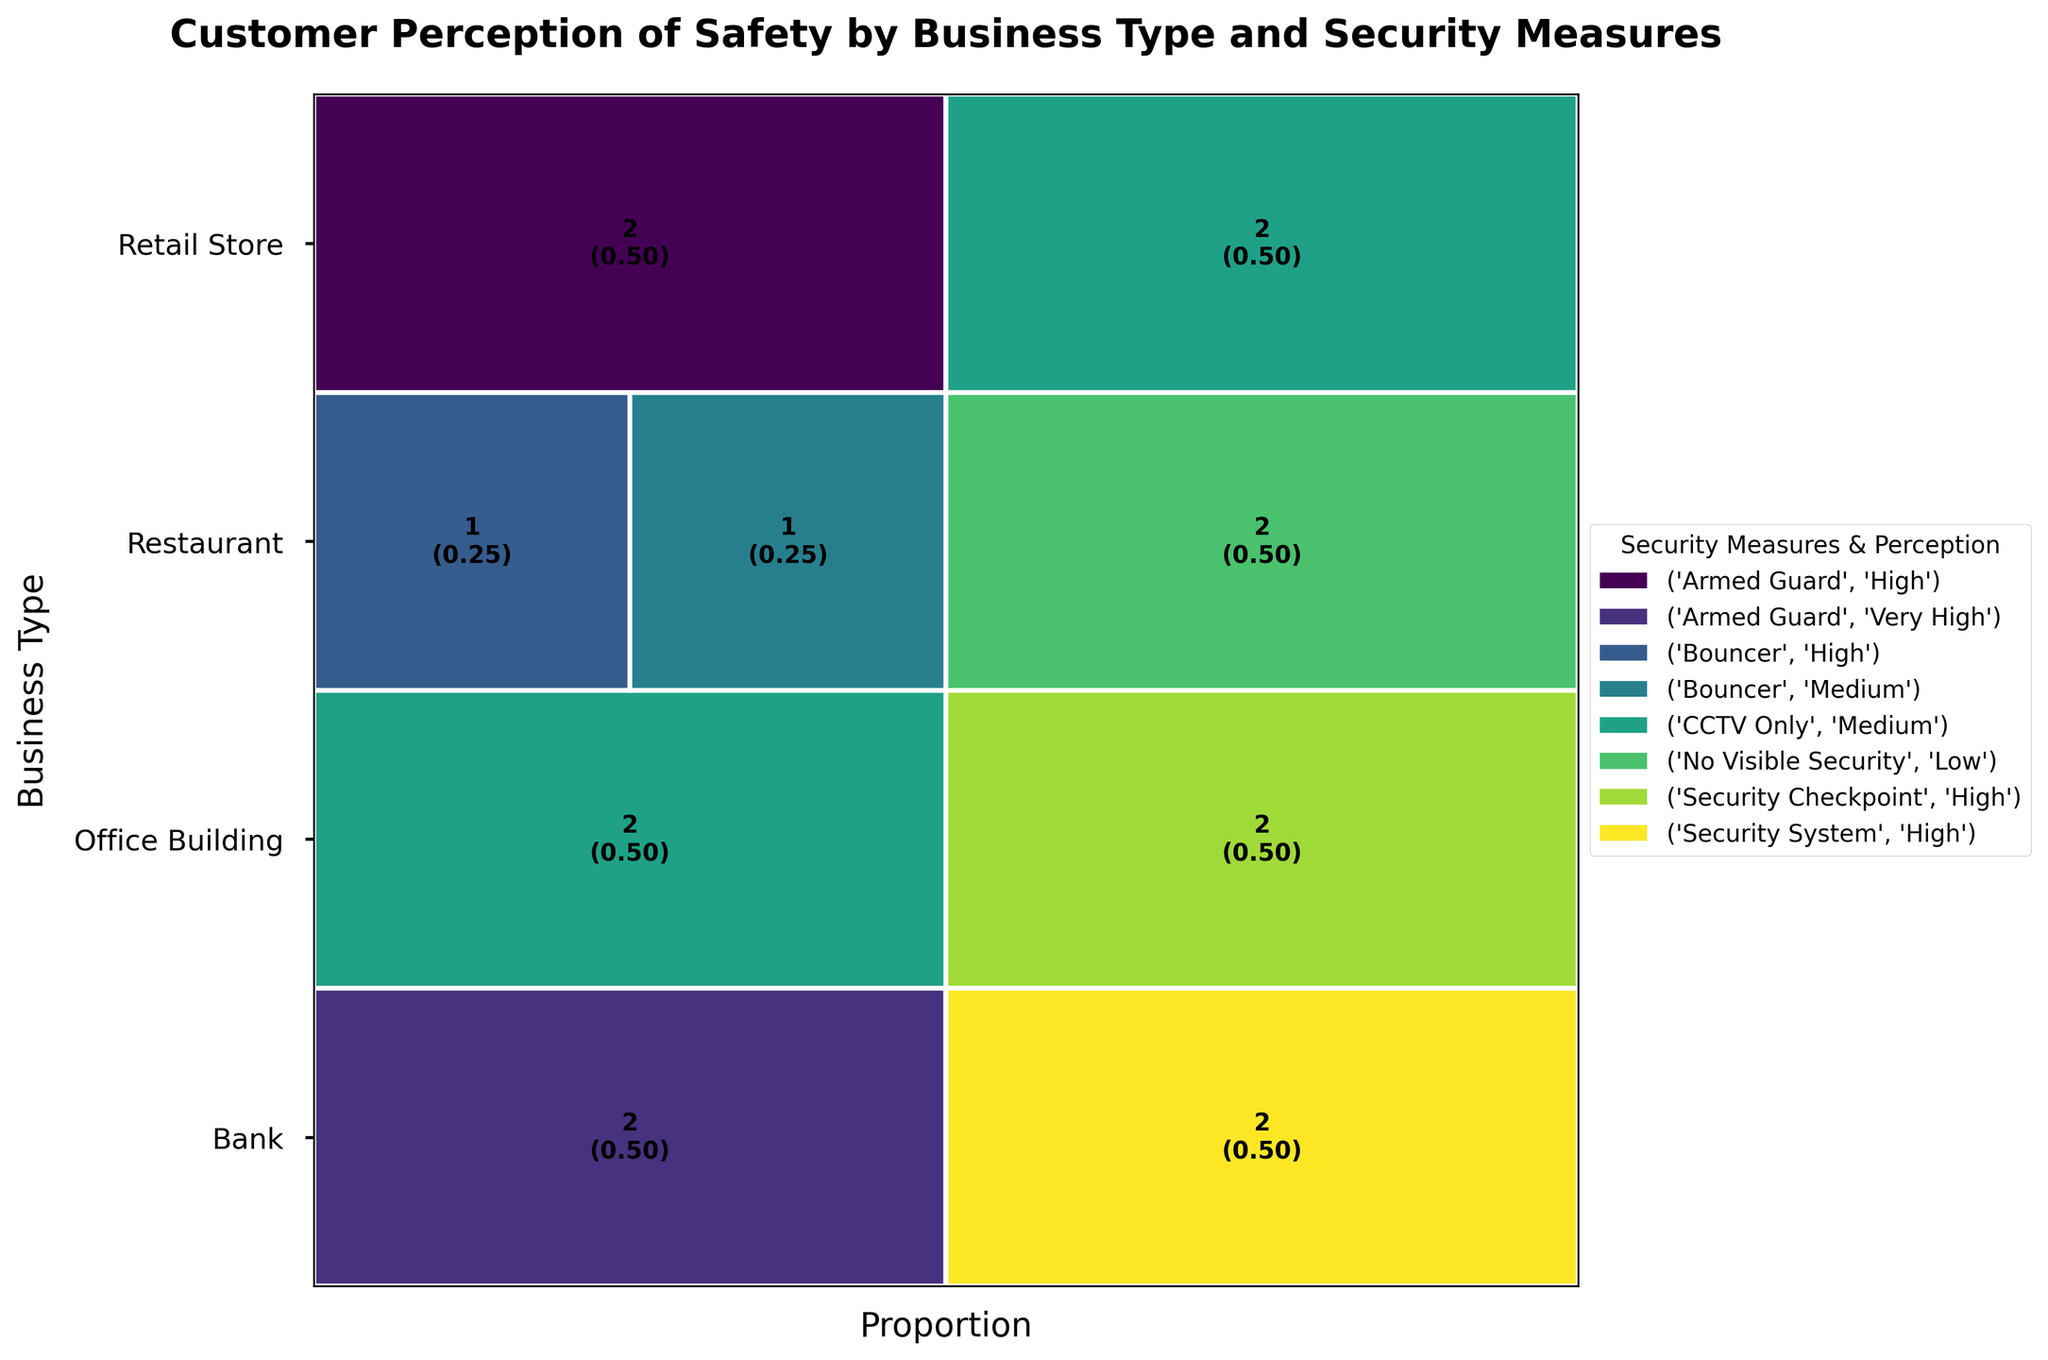What are the security measures and perception of safety for Banks in Urban locations? The figure shows different security measures and perception categories by business type and location. For Banks in Urban locations, the security measures and perception are displayed: "Armed Guard" with "Very High" safety, and "Security System" with "High" safety.
Answer: Armed Guard: Very High, Security System: High Which business type in Suburban locations has the highest perceived safety with CCTV Only? Analyzing the suburban rows, we look for the highest perception of safety with the "CCTV Only" category. The data shows "Retail Store" and "Office Building" with "Medium" safety for CCTV Only in Suburban locations. Both are tied.
Answer: Retail Store, Office Building Which business type has the highest level of perceived safety overall? By comparing all the business types and their associated safety perceptions, the category that stands out the most appears under the Banks with "Armed Guard" recorded as "Very High" in both Urban and Suburban locations.
Answer: Bank Do Restaurants in Urban locations have any perceptions of safety rated as "High"? Observing the security measures and perception for Restaurants in Urban locations, the data shows the "Bouncer" category with a "High" perception of safety.
Answer: Yes How does the perception of safety for Retail Stores in Urban locations with CCTV Only compare to those in Suburban locations? Comparing "CCTV Only" for Retail Stores in both urban and suburban locations, both perceptions of safety are rated "Medium."
Answer: Both are Medium Which security measure in Urban Retail Stores is associated with a "High" perception of safety? Reviewing the figure, the "Armed Guard" security measure for Urban Retail Stores is associated with a "High" safety perception.
Answer: Armed Guard What is the perception of safety for Office Buildings in Suburban locations with Security Checkpoints? Looking at the data for Suburban Office Buildings with "Security Checkpoints," the perceived safety is noted as "High."
Answer: High Are there any business types in Urban locations without visible security measures and what is their perception of safety? The figure shows that "Restaurants" in Urban locations have "No Visible Security" measures and their perception of safety is "Low."
Answer: Restaurants: Low 